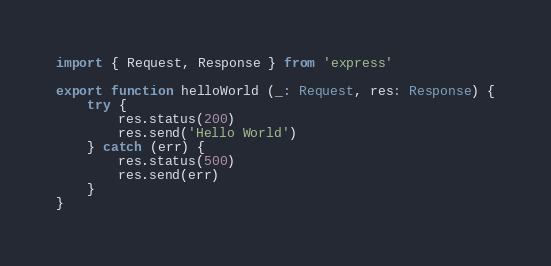<code> <loc_0><loc_0><loc_500><loc_500><_TypeScript_>import { Request, Response } from 'express'

export function helloWorld (_: Request, res: Response) {
    try {
        res.status(200)
        res.send('Hello World')
    } catch (err) {
        res.status(500)
        res.send(err)
    }
}
</code> 